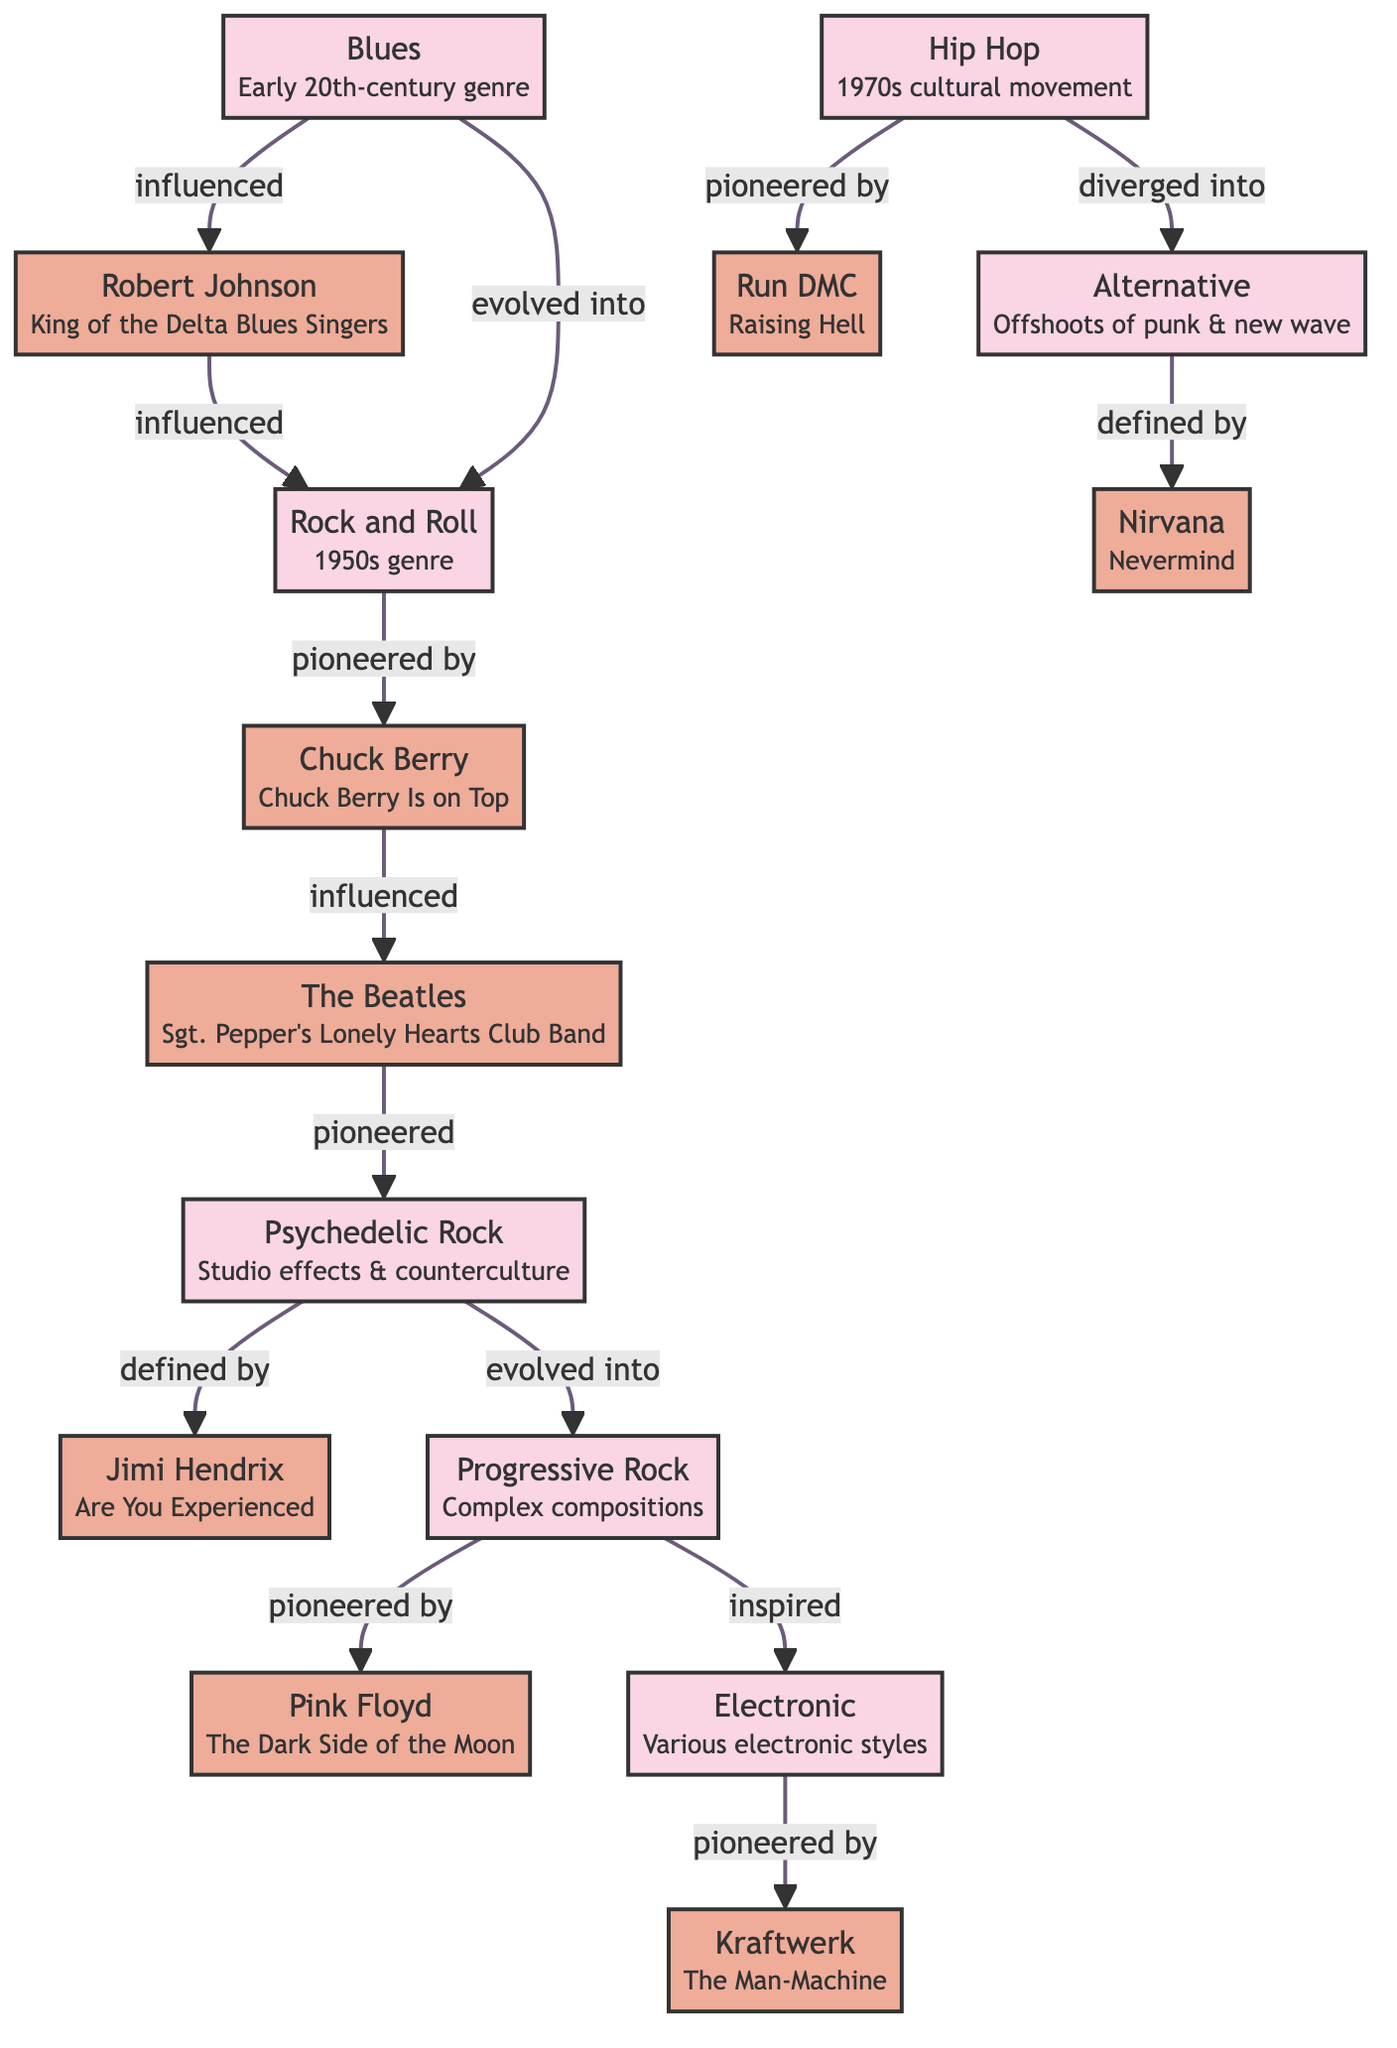What genre evolved into Rock and Roll? By examining the directed edges in the diagram, we can see the edge labeled "evolved into" from the node Blues to the node Rock and Roll. This indicates that Blues is the genre that evolved into Rock and Roll.
Answer: Blues Who is defined by Psychedelic Rock? The diagram shows an edge labeled "defined by" going from the node Psychedelic Rock to the node Jimi Hendrix. This means that Jimi Hendrix is the artist that is defined by the genre Psychedelic Rock.
Answer: Jimi Hendrix Which artist pioneered Progressive Rock? Looking at the edges, we find that the node labeled Progressive Rock has an edge labeled "pioneered by" pointing to the node Pink Floyd. This confirms that Pink Floyd is the artist that pioneered Progressive Rock.
Answer: Pink Floyd How many edges are shown in the diagram? By counting the directed edges listed in the data, we see there are a total of 13 edges connecting various nodes in the diagram, indicating relationships between genres and artists.
Answer: 13 Which genre diverged into Alternative? The diagram indicates that there is an edge labeled "diverged into" linking the node Hip Hop to the node Alternative. This shows that Hip Hop is the genre that diverged into Alternative.
Answer: Hip Hop Who influenced Rock and Roll? The diagram has two edges indicating influence on Rock and Roll – from Blues to Rock and Roll and from Robert Johnson to Rock and Roll. Thus, both Blues and Robert Johnson influenced Rock and Roll.
Answer: Blues, Robert Johnson What role did The Beatles play in the evolution of Psychedelic Rock? According to the edges, The Beatles are linked to Psychedelic Rock by the edge labeled "pioneered." This indicates that they played a pioneering role in the evolution of this genre.
Answer: pioneered What is the key album of Nirvana? The node representing Nirvana includes the description mentioning their key album, which is "Nevermind." This gives a direct answer regarding the key album associated with Nirvana.
Answer: Nevermind Which genre inspired Electronic? The edge labeled "inspired" shows that the genre Progressive Rock has a direct relationship with Electronic, specifically indicating that Progressive Rock inspired the genre Electronic.
Answer: Progressive Rock 